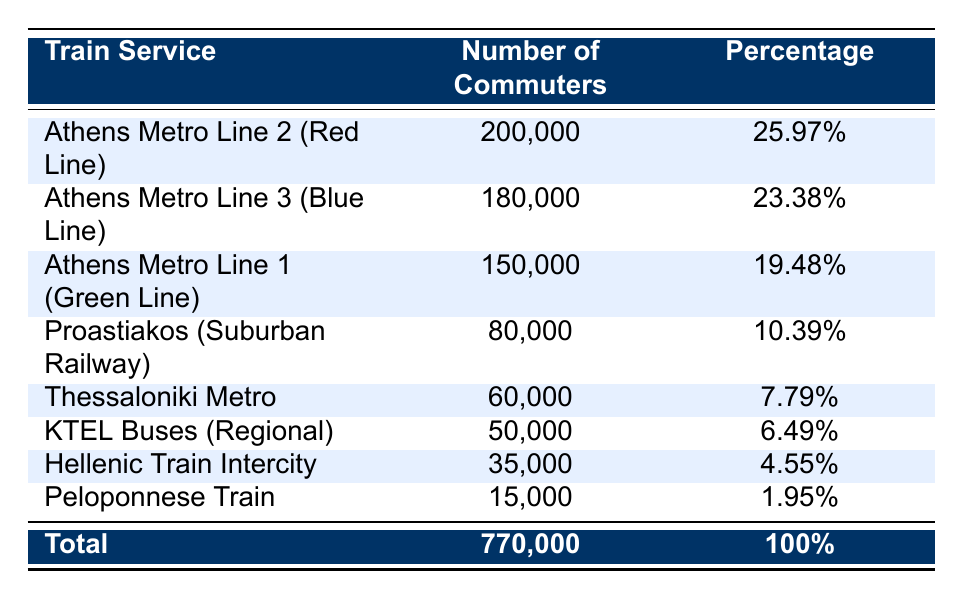What is the most popular train service among commuters? The most popular train service can be identified by the highest number of commuters. In the table, Athens Metro Line 2 (Red Line) has 200,000 commuters, which is the largest figure compared to other services.
Answer: Athens Metro Line 2 (Red Line) What percentage of total commuters use the Hellenic Train Intercity service? To find the percentage of total commuters that use the Hellenic Train Intercity, we take the number of commuters for that service (35,000) and divide it by the total number of commuters (770,000), then multiply by 100. The calculation is (35,000/770,000) * 100 = 4.55%.
Answer: 4.55% How many more commuters use the Athens Metro Line 3 than the Thessaloniki Metro? We subtract the number of commuters for Thessaloniki Metro (60,000) from those for Athens Metro Line 3 (180,000). The calculation is 180,000 - 60,000 = 120,000.
Answer: 120,000 Is the number of commuters on the Proastiakos (Suburban Railway) greater than those of the Peloponnese Train? To answer this, we compare the two numbers: Proastiakos has 80,000 commuters and the Peloponnese Train has 15,000. Since 80,000 is greater than 15,000, the statement is true.
Answer: Yes What is the total number of commuters for all train services except the KTEL Buses (Regional)? To find this total, we add the number of commuters for all services except KTEL Buses (50,000). The numbers to be summed are: Athens Metro Line 1 (150,000), Athens Metro Line 2 (200,000), Athens Metro Line 3 (180,000), Proastiakos (80,000), Thessaloniki Metro (60,000), Hellenic Train Intercity (35,000), and Peloponnese Train (15,000). The total is 150,000 + 200,000 + 180,000 + 80,000 + 60,000 + 35,000 + 15,000 = 720,000.
Answer: 720,000 How many train services have more than 100,000 commuters? We can find this by looking at the number of commuters for each service. The services with more than 100,000 commuters are Athens Metro Line 2 (200,000), Athens Metro Line 3 (180,000), and Athens Metro Line 1 (150,000). There are three services meeting this criterion.
Answer: 3 